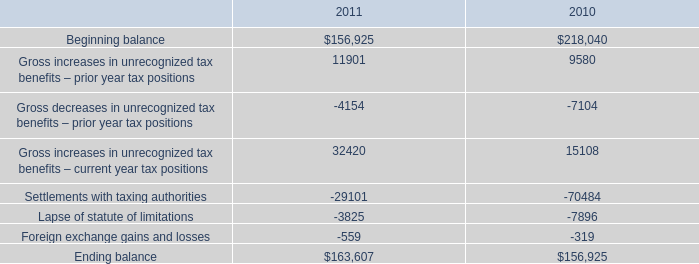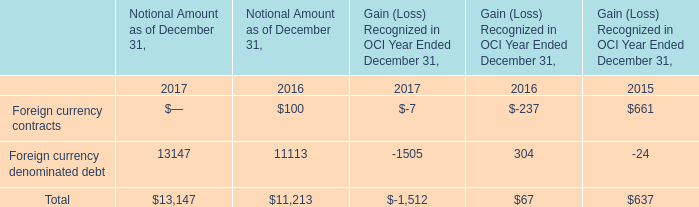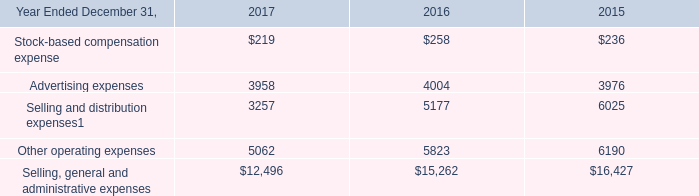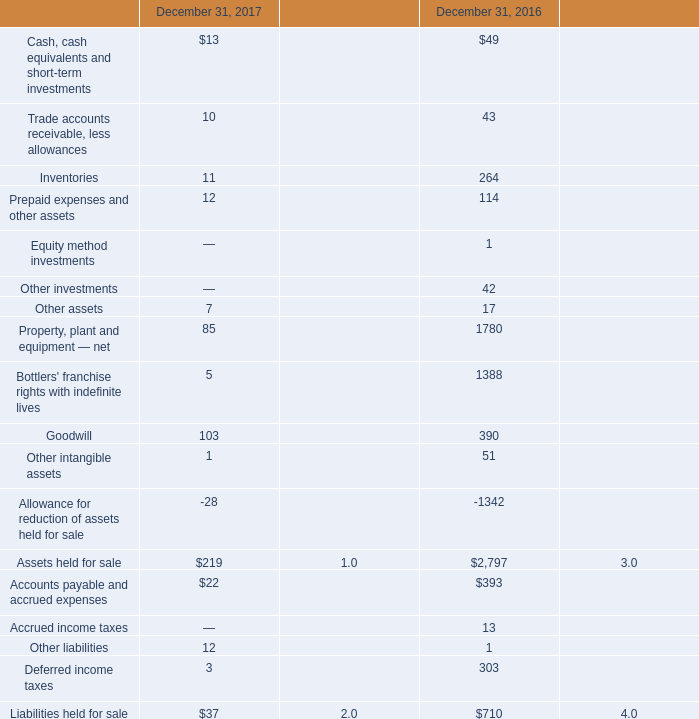what's the total amount of Lapse of statute of limitations of 2010, Other operating expenses of 2017, and Gross increases in unrecognized tax benefits – prior year tax positions of 2010 ? 
Computations: ((7896.0 + 5062.0) + 9580.0)
Answer: 22538.0. 